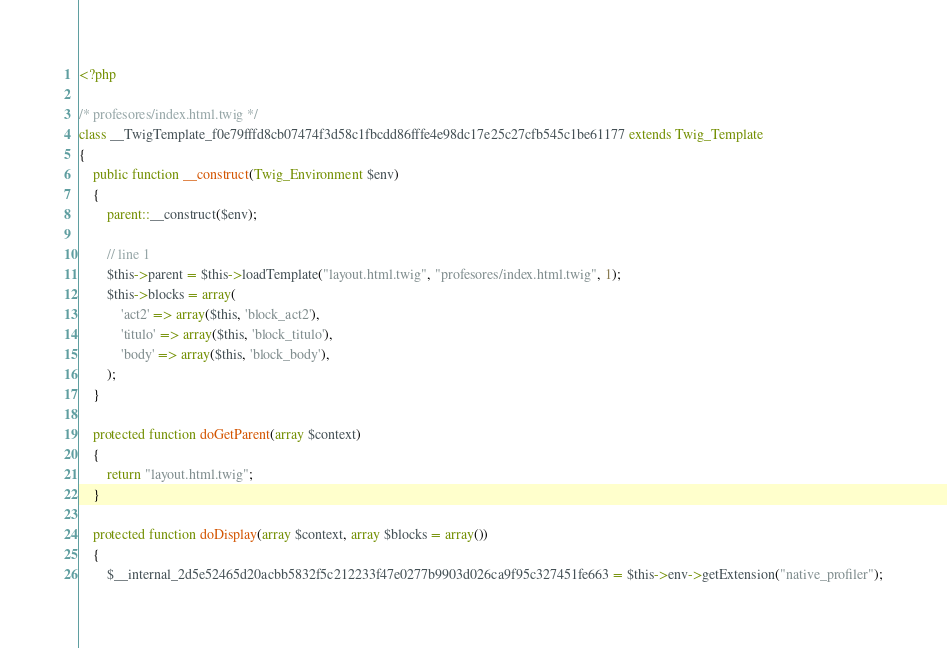<code> <loc_0><loc_0><loc_500><loc_500><_PHP_><?php

/* profesores/index.html.twig */
class __TwigTemplate_f0e79fffd8cb07474f3d58c1fbcdd86fffe4e98dc17e25c27cfb545c1be61177 extends Twig_Template
{
    public function __construct(Twig_Environment $env)
    {
        parent::__construct($env);

        // line 1
        $this->parent = $this->loadTemplate("layout.html.twig", "profesores/index.html.twig", 1);
        $this->blocks = array(
            'act2' => array($this, 'block_act2'),
            'titulo' => array($this, 'block_titulo'),
            'body' => array($this, 'block_body'),
        );
    }

    protected function doGetParent(array $context)
    {
        return "layout.html.twig";
    }

    protected function doDisplay(array $context, array $blocks = array())
    {
        $__internal_2d5e52465d20acbb5832f5c212233f47e0277b9903d026ca9f95c327451fe663 = $this->env->getExtension("native_profiler");</code> 